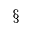<formula> <loc_0><loc_0><loc_500><loc_500>^ { \ } m a t h s e c t i o n</formula> 